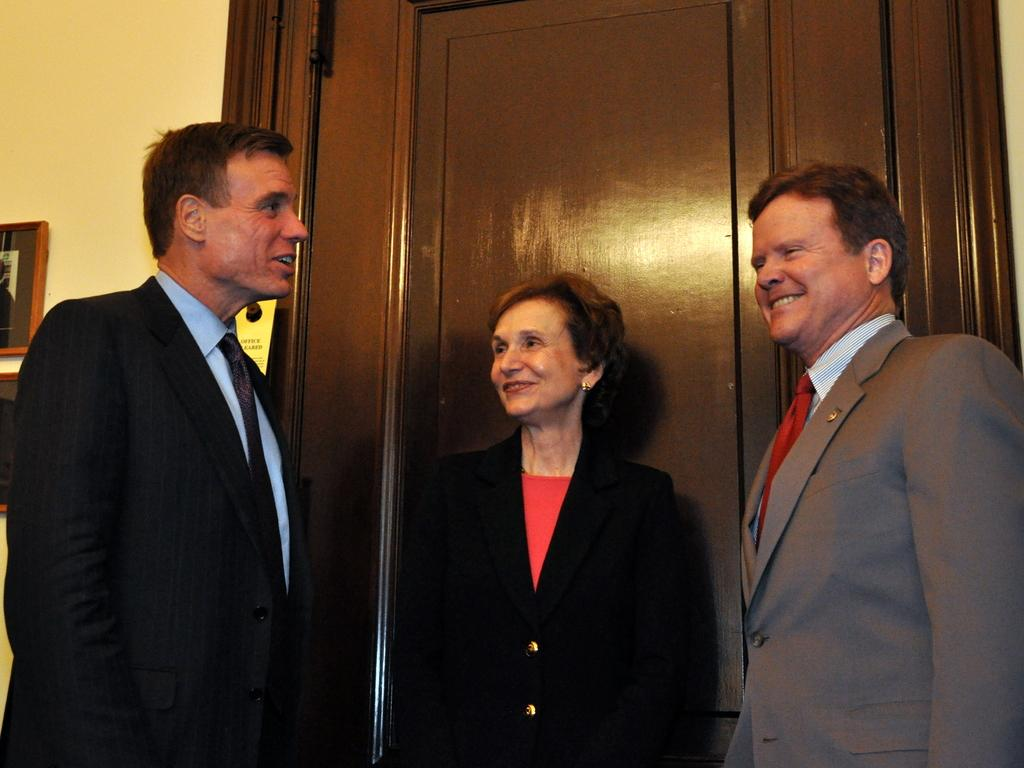How many people are in the image? There are three persons in the image. What expressions do the persons have on their faces? The persons are wearing smiles on their faces. What can be seen behind the persons? There is a door visible behind the persons. What is on the wall behind the persons? There is a wall with photo frames attached to it on the backside of the image. What type of liquid is being poured from the cherry in the image? There is no liquid or cherry present in the image. How is the knot tied on the wall in the image? There is no knot present on the wall in the image; it only has photo frames attached to it. 